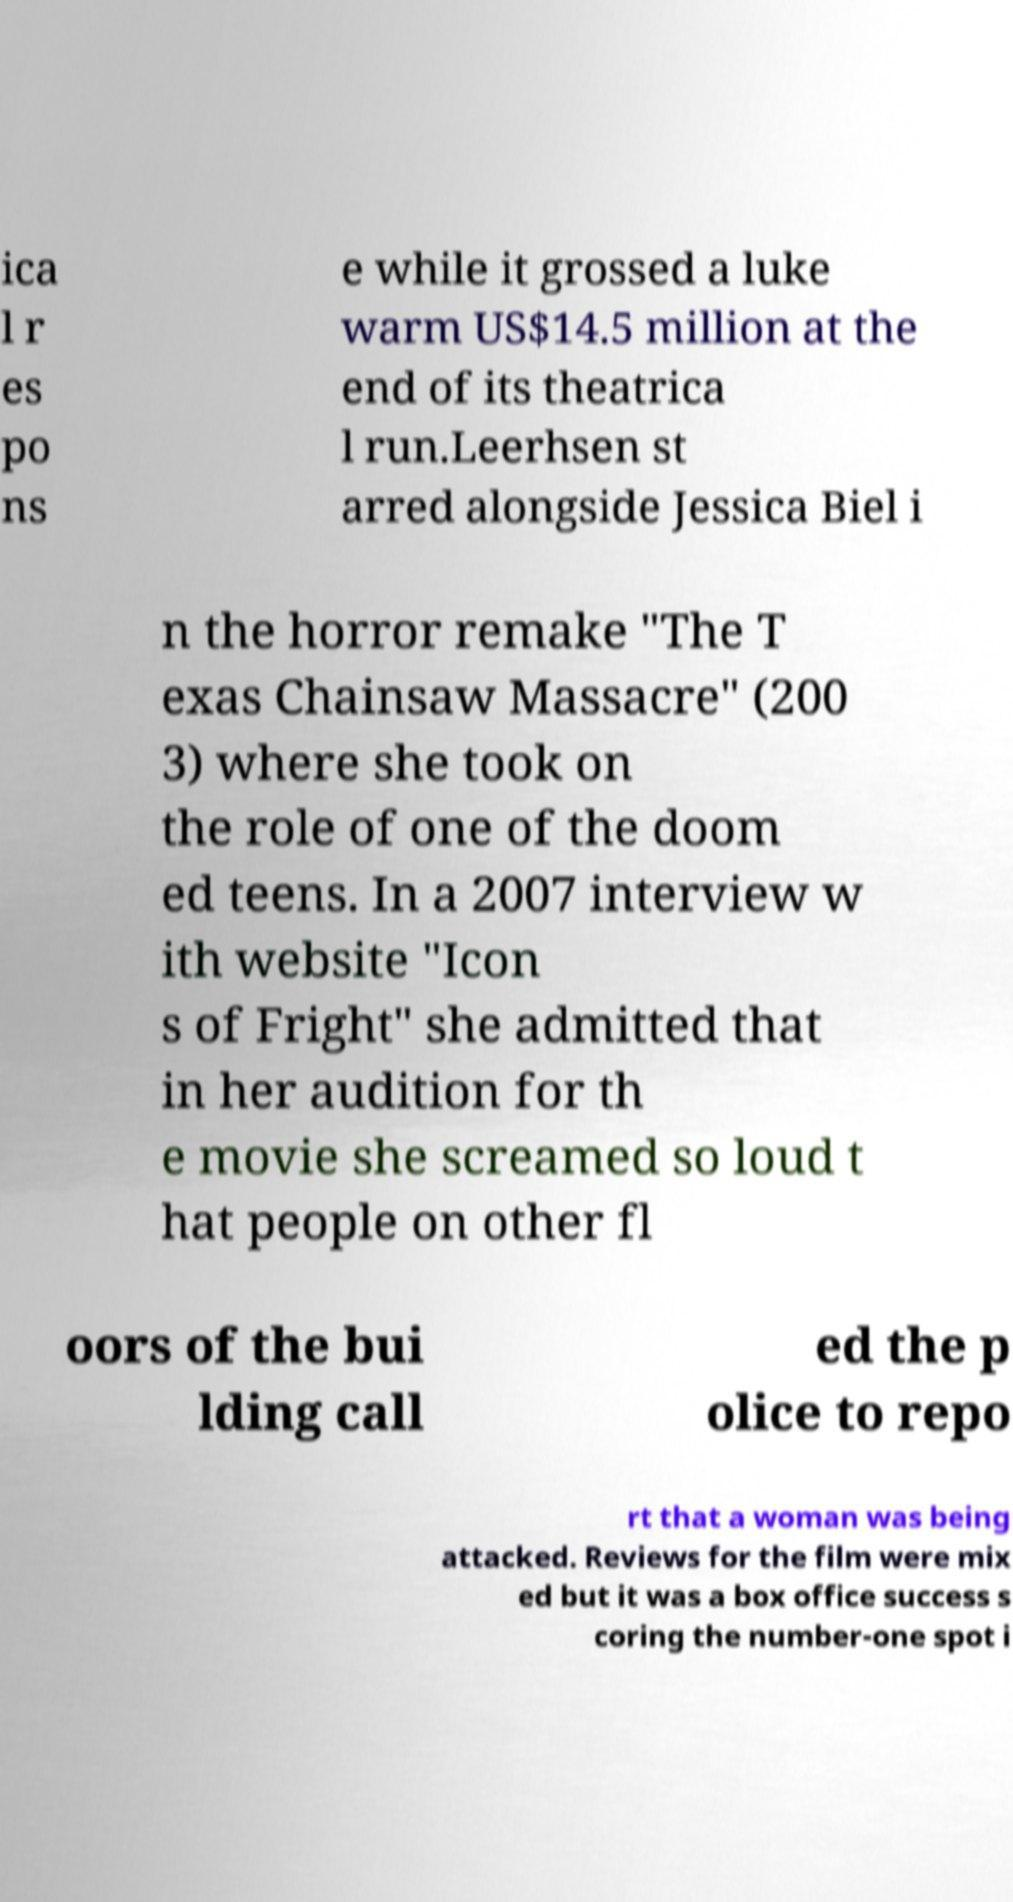Please identify and transcribe the text found in this image. ica l r es po ns e while it grossed a luke warm US$14.5 million at the end of its theatrica l run.Leerhsen st arred alongside Jessica Biel i n the horror remake "The T exas Chainsaw Massacre" (200 3) where she took on the role of one of the doom ed teens. In a 2007 interview w ith website "Icon s of Fright" she admitted that in her audition for th e movie she screamed so loud t hat people on other fl oors of the bui lding call ed the p olice to repo rt that a woman was being attacked. Reviews for the film were mix ed but it was a box office success s coring the number-one spot i 